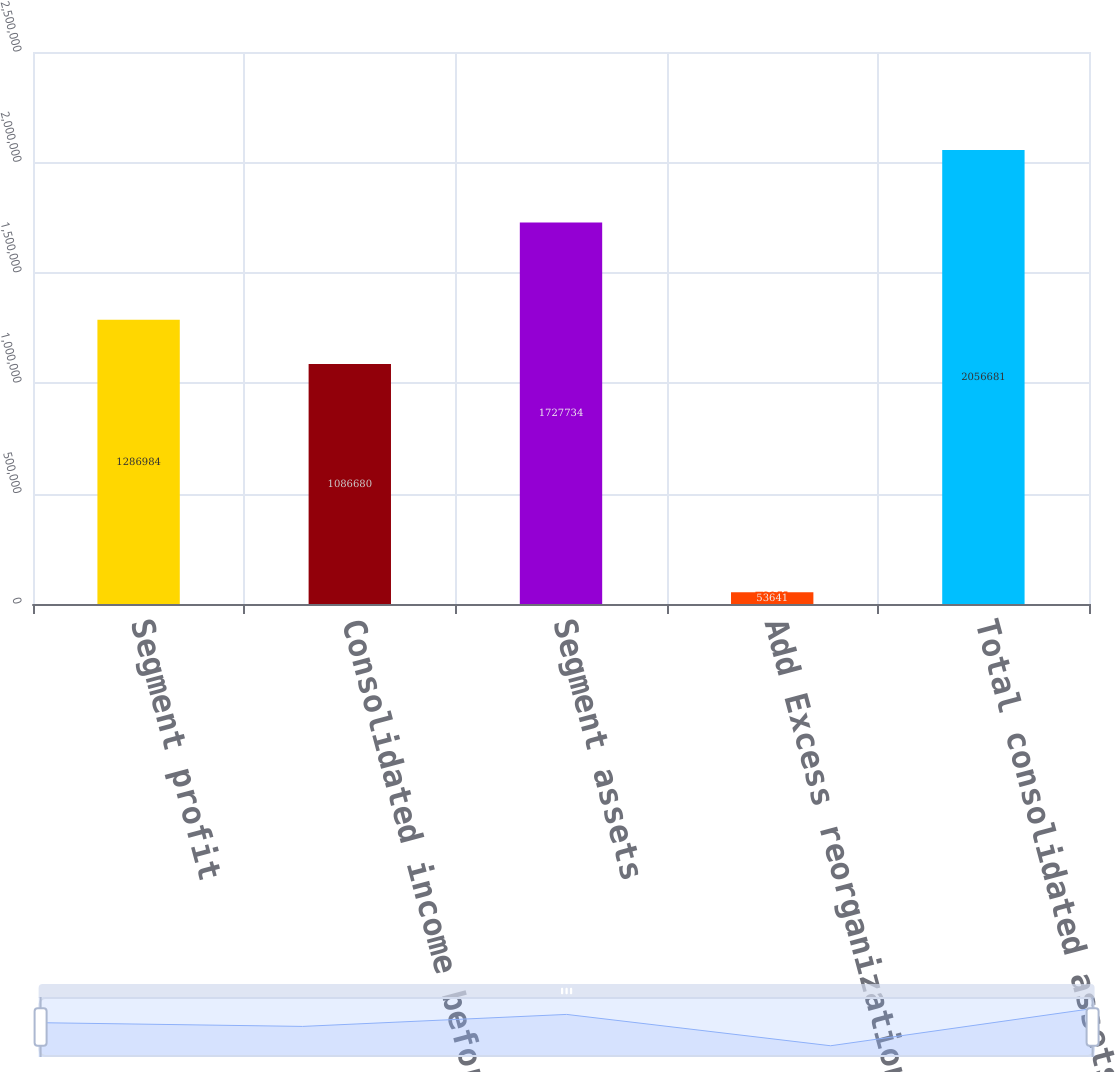Convert chart to OTSL. <chart><loc_0><loc_0><loc_500><loc_500><bar_chart><fcel>Segment profit<fcel>Consolidated income before<fcel>Segment assets<fcel>Add Excess reorganization<fcel>Total consolidated assets<nl><fcel>1.28698e+06<fcel>1.08668e+06<fcel>1.72773e+06<fcel>53641<fcel>2.05668e+06<nl></chart> 